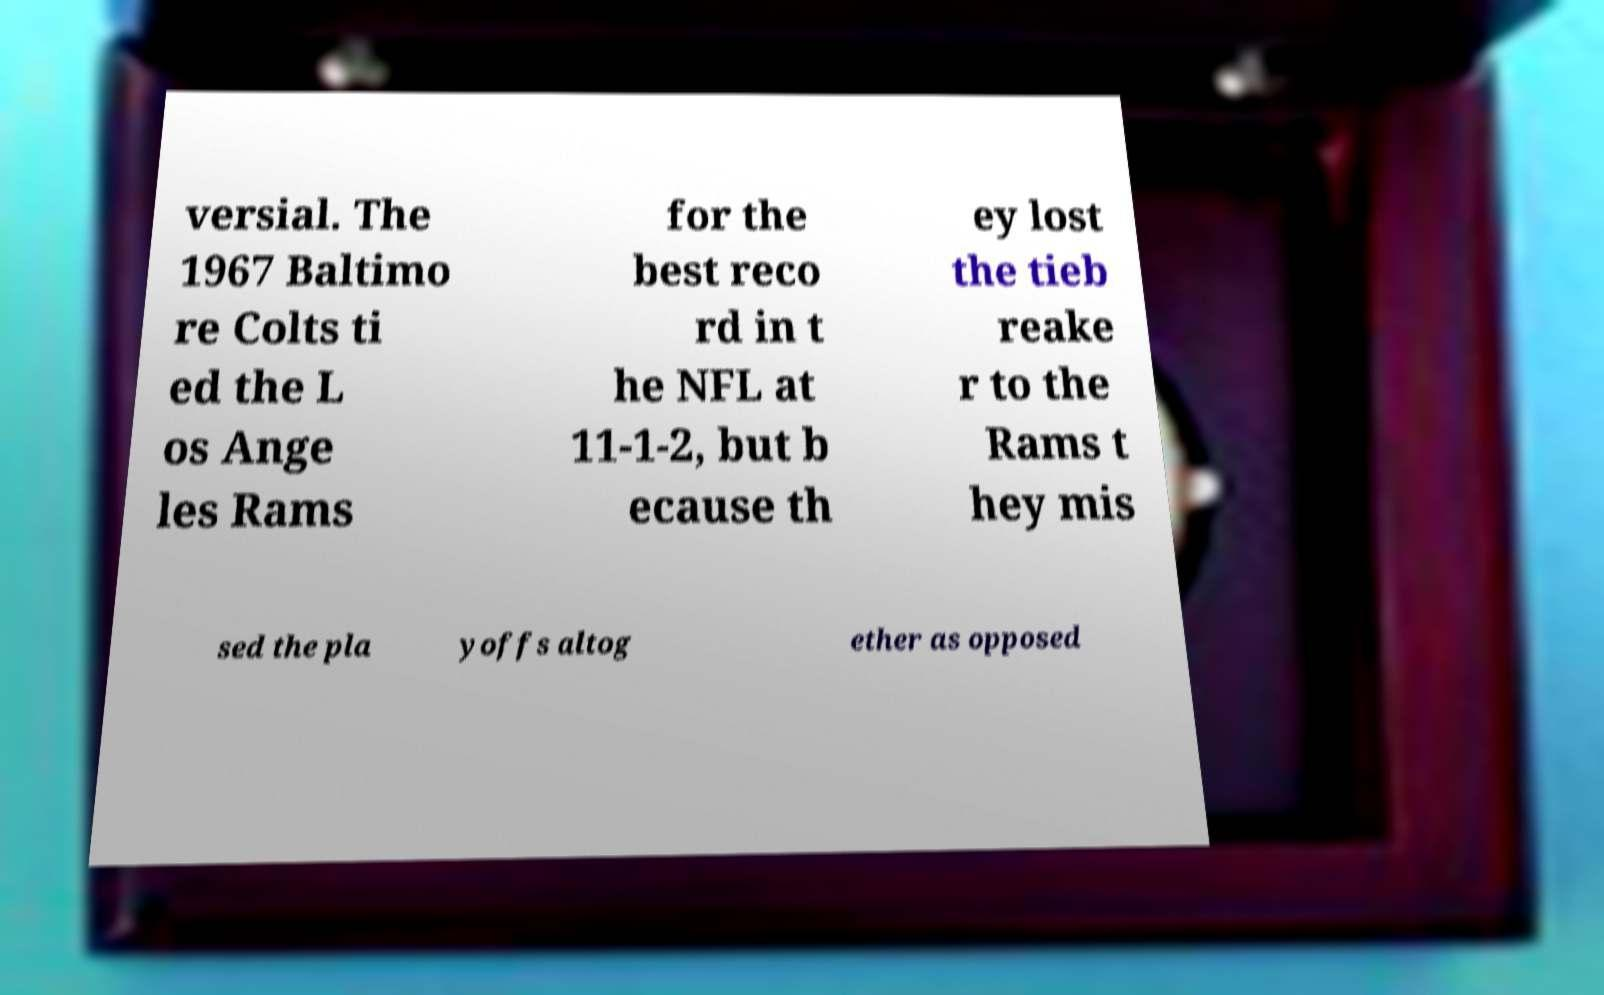Could you extract and type out the text from this image? versial. The 1967 Baltimo re Colts ti ed the L os Ange les Rams for the best reco rd in t he NFL at 11-1-2, but b ecause th ey lost the tieb reake r to the Rams t hey mis sed the pla yoffs altog ether as opposed 